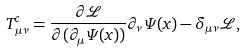Convert formula to latex. <formula><loc_0><loc_0><loc_500><loc_500>T ^ { c } _ { \mu \nu } = \frac { \partial \mathcal { L } } { \partial ( \partial _ { \mu } \Psi ( x ) ) } \partial _ { \nu } \Psi ( x ) - \delta _ { \mu \nu } \mathcal { L } ,</formula> 